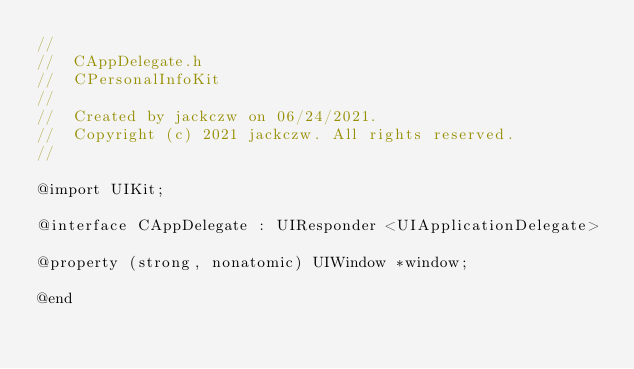Convert code to text. <code><loc_0><loc_0><loc_500><loc_500><_C_>//
//  CAppDelegate.h
//  CPersonalInfoKit
//
//  Created by jackczw on 06/24/2021.
//  Copyright (c) 2021 jackczw. All rights reserved.
//

@import UIKit;

@interface CAppDelegate : UIResponder <UIApplicationDelegate>

@property (strong, nonatomic) UIWindow *window;

@end
</code> 